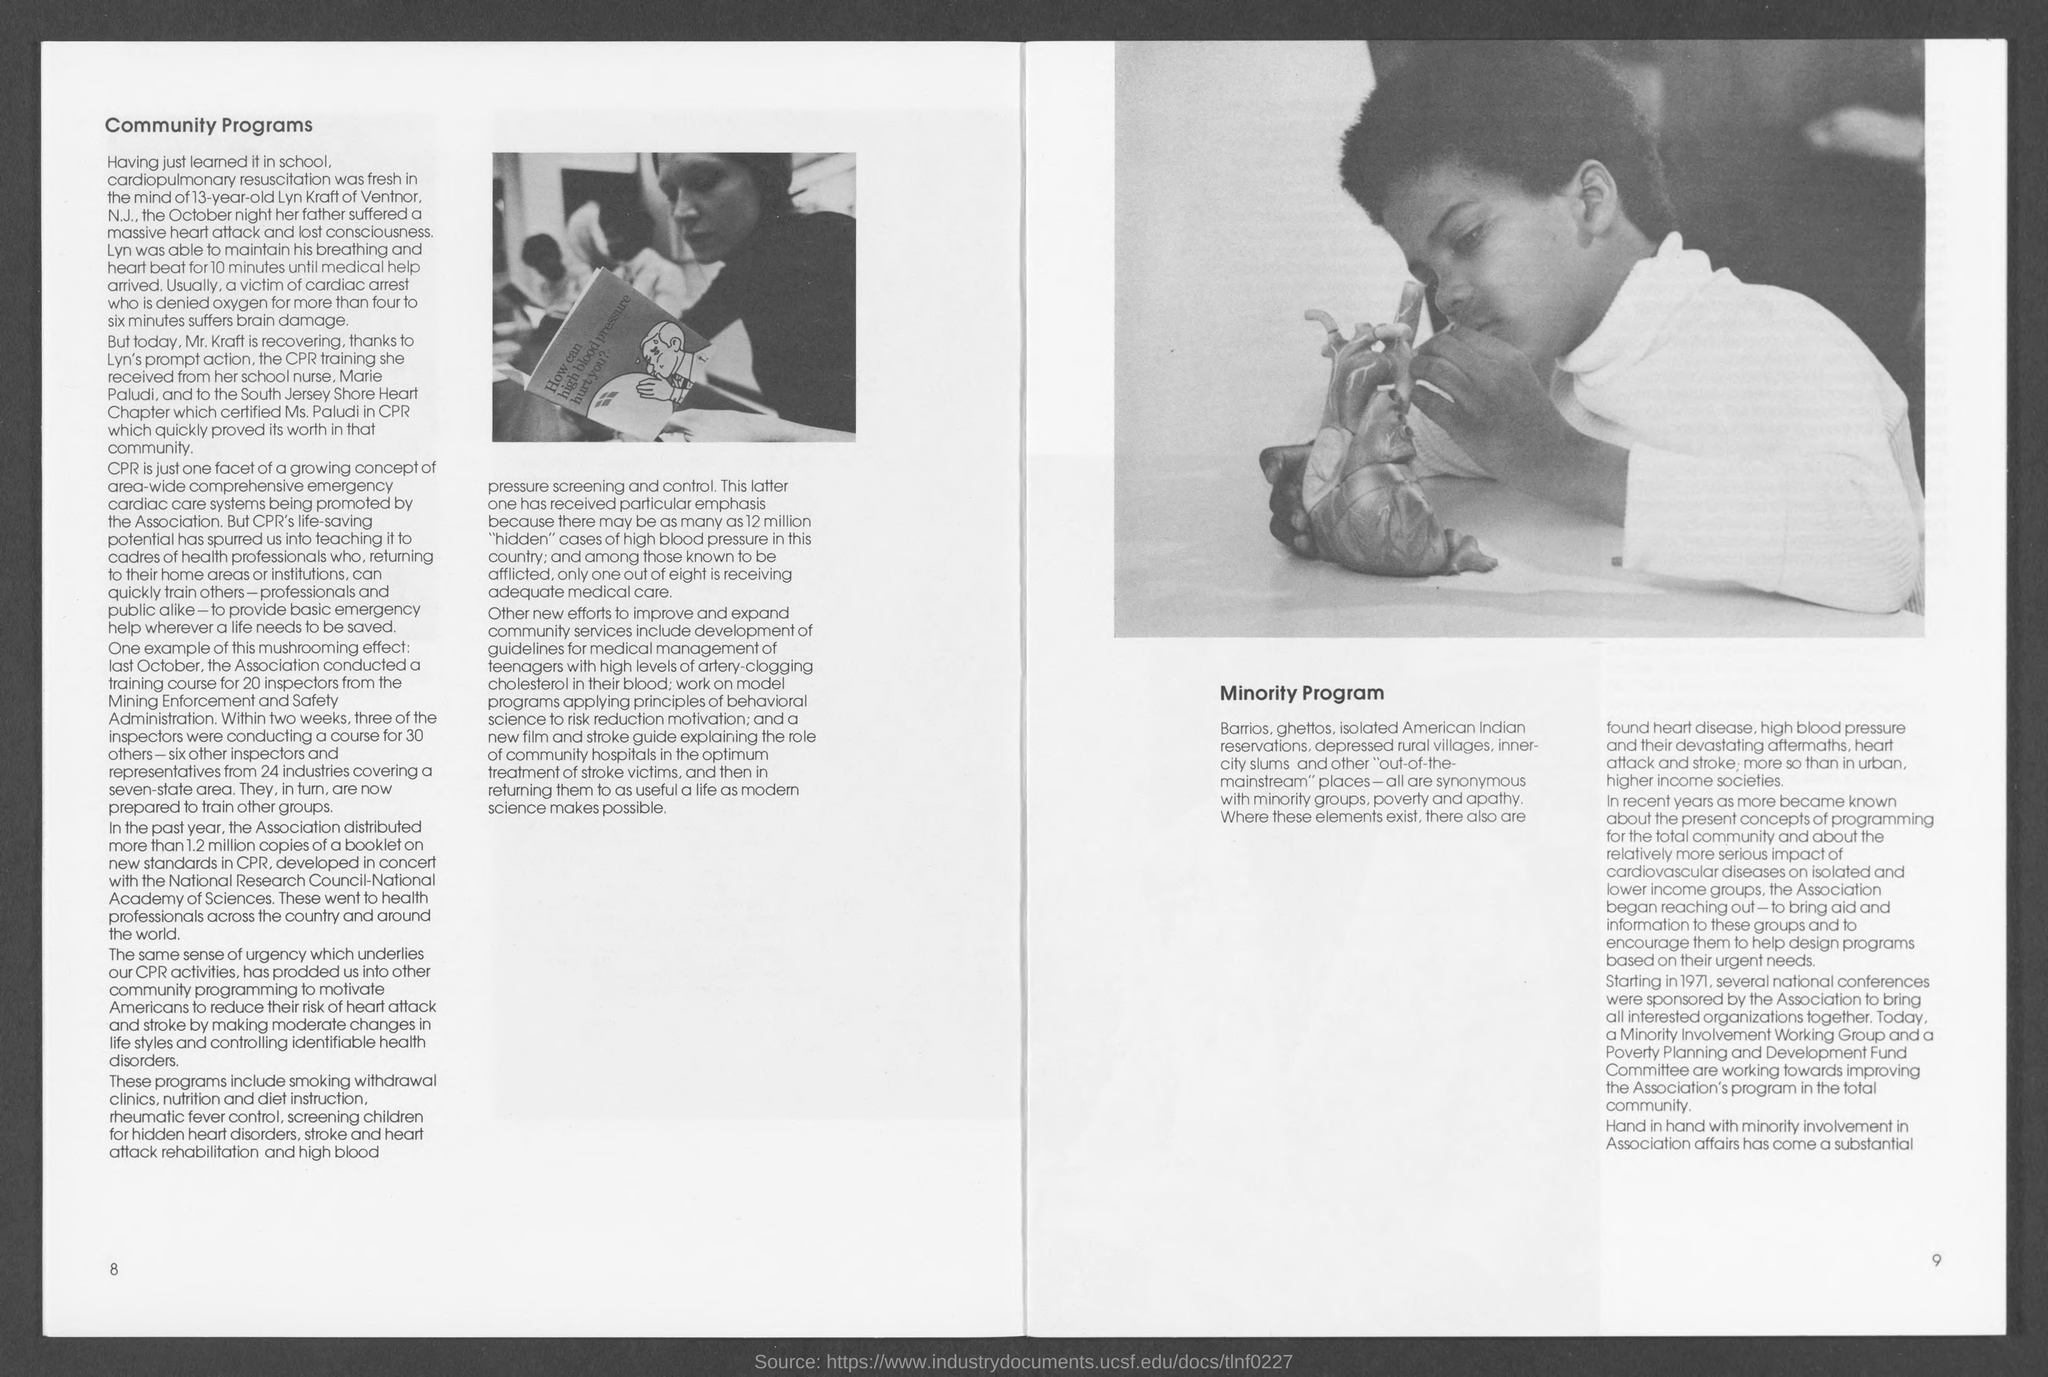What is the number at bottom left page?
Offer a very short reply. 8. What is the number at bottom right page ?
Ensure brevity in your answer.  9. What is the heading of left page ?
Offer a very short reply. Community Programs. 